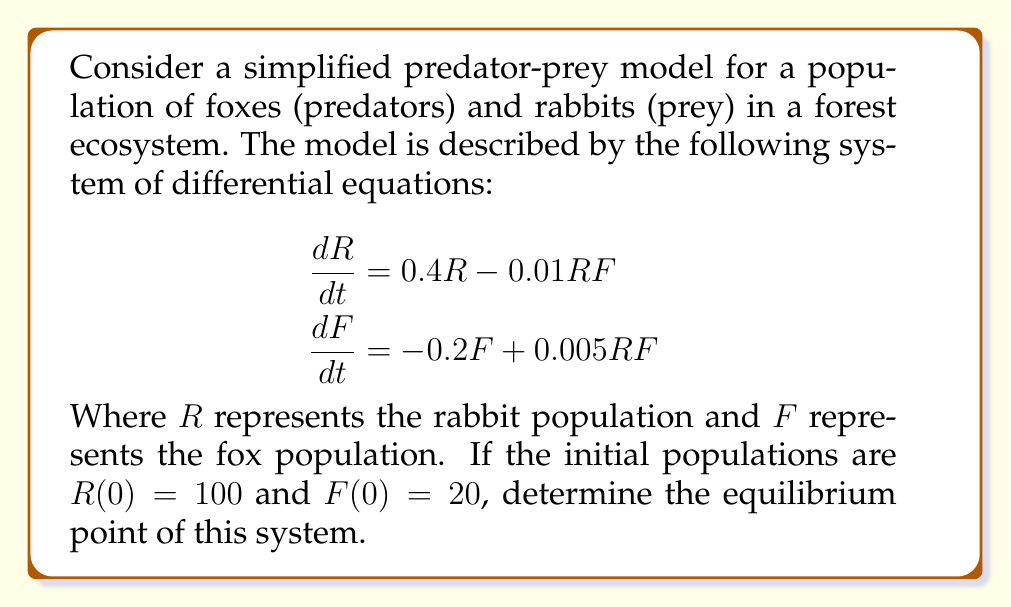Can you answer this question? To find the equilibrium point, we need to set both equations equal to zero and solve for R and F:

1) Set $\frac{dR}{dt} = 0$ and $\frac{dF}{dt} = 0$:

   $$\begin{aligned}
   0 &= 0.4R - 0.01RF \\
   0 &= -0.2F + 0.005RF
   \end{aligned}$$

2) From the first equation:
   
   $$0.4R - 0.01RF = 0$$
   $$R(0.4 - 0.01F) = 0$$

   This is satisfied when $R = 0$ or $F = 40$.

3) From the second equation:

   $$-0.2F + 0.005RF = 0$$
   $$F(-0.2 + 0.005R) = 0$$

   This is satisfied when $F = 0$ or $R = 40$.

4) The non-zero equilibrium point occurs when $F = 40$ and $R = 40$.

5) To verify, substitute these values back into both original equations:

   $$\begin{aligned}
   \frac{dR}{dt} &= 0.4(40) - 0.01(40)(40) = 16 - 16 = 0 \\
   \frac{dF}{dt} &= -0.2(40) + 0.005(40)(40) = -8 + 8 = 0
   \end{aligned}$$

Therefore, the equilibrium point is $(R, F) = (40, 40)$.
Answer: $(40, 40)$ 